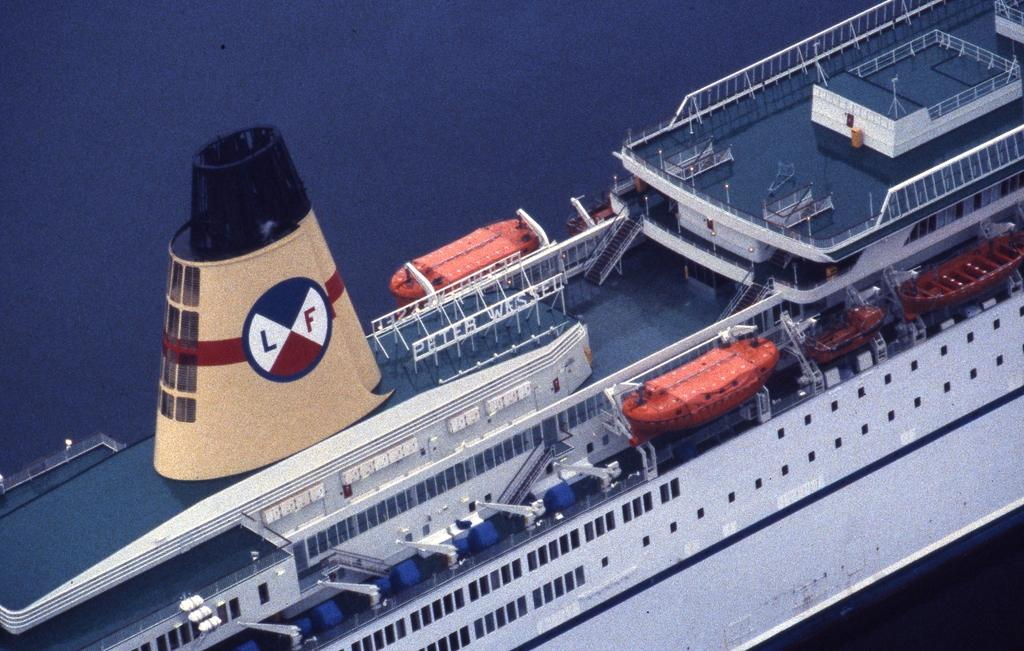What is the main subject of the image? The main subject of the image is a ship. What can be said about the color of the ship? The ship is white in color. What features are present on the ship? The ship has railings, steps, windows, and doors. What type of celery can be seen growing on the ship in the image? There is no celery present in the image; it features a white ship with various features. 